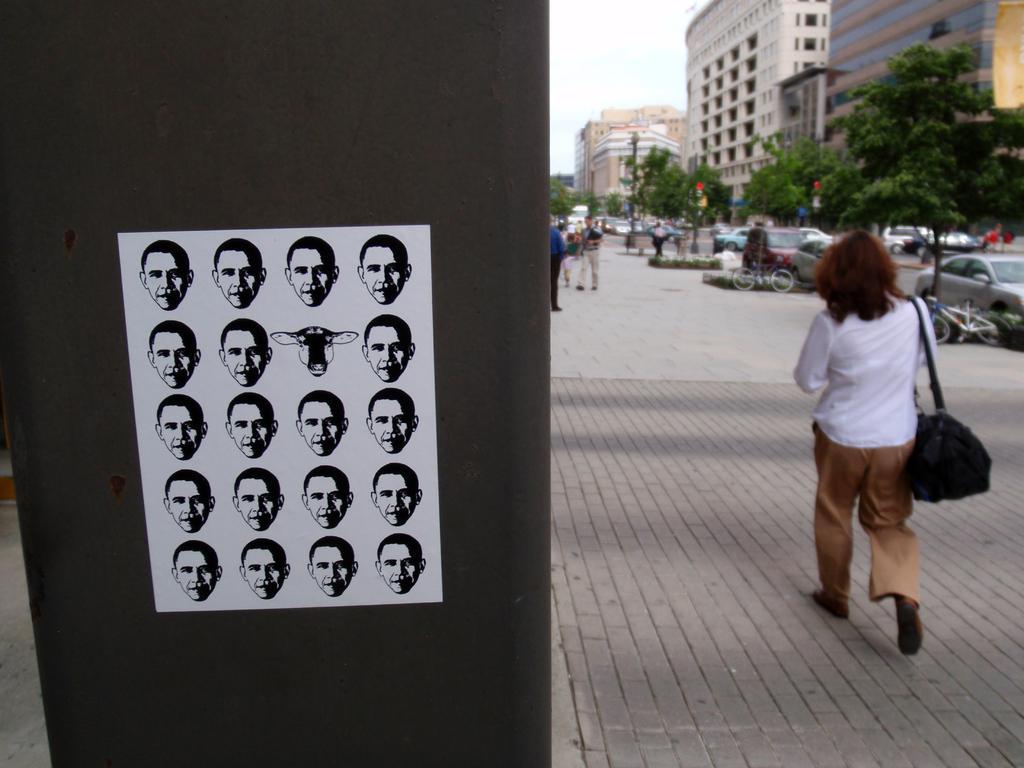Describe this image in one or two sentences. At the left side of the image there is a black board. On the black board there is a white paper with few faces on it. At the right side of the image on the floor to the front there is a lady with white shirt and brown pant is walking. In the background there are cars, bicycles, trees and few people are walking on the floor. And also there are buildings with glass windows and walls. 